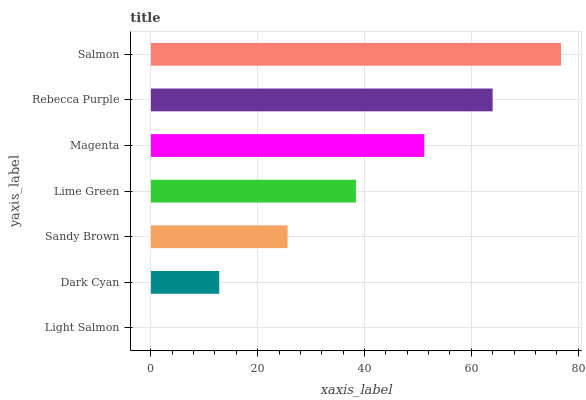Is Light Salmon the minimum?
Answer yes or no. Yes. Is Salmon the maximum?
Answer yes or no. Yes. Is Dark Cyan the minimum?
Answer yes or no. No. Is Dark Cyan the maximum?
Answer yes or no. No. Is Dark Cyan greater than Light Salmon?
Answer yes or no. Yes. Is Light Salmon less than Dark Cyan?
Answer yes or no. Yes. Is Light Salmon greater than Dark Cyan?
Answer yes or no. No. Is Dark Cyan less than Light Salmon?
Answer yes or no. No. Is Lime Green the high median?
Answer yes or no. Yes. Is Lime Green the low median?
Answer yes or no. Yes. Is Magenta the high median?
Answer yes or no. No. Is Dark Cyan the low median?
Answer yes or no. No. 